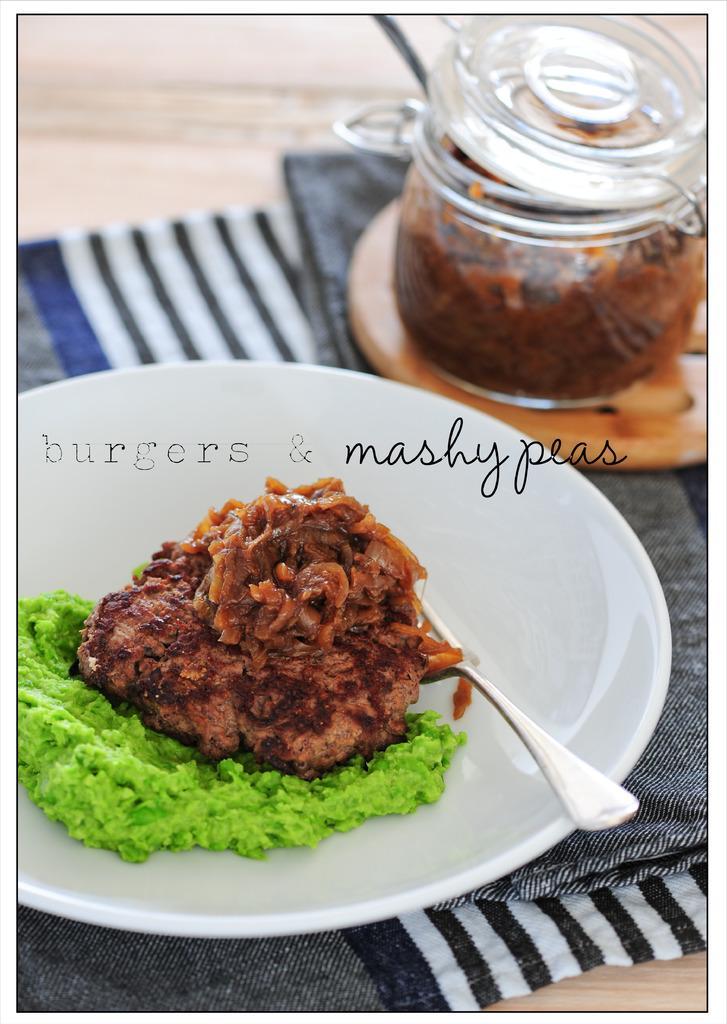Describe this image in one or two sentences. In this image we can see a food item on the plate, it is in brown color, here is the spoon, beside here is the jar, here is the cloth on the table. 